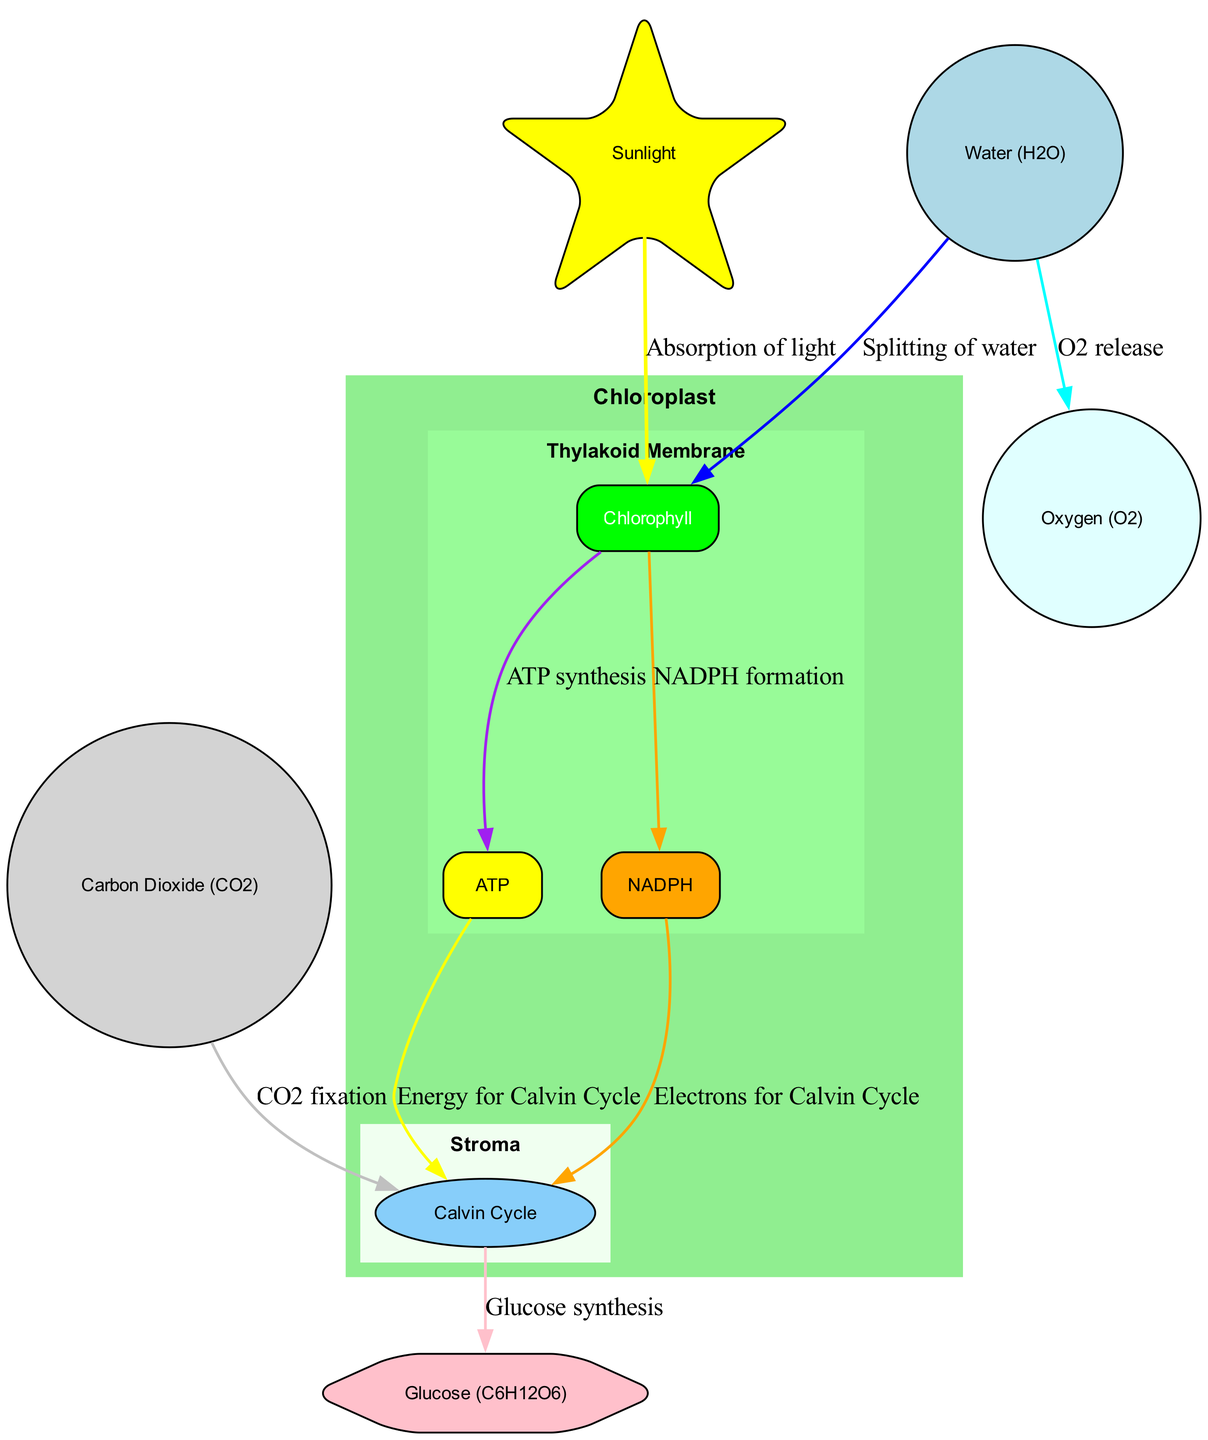What is the site of photosynthesis in plant cells? The diagram indicates that chloroplasts are the site of photosynthesis in plant cells, as labeled.
Answer: Chloroplast How many main components are identified in the chloroplast? The diagram lists six main components: Chloroplast, Thylakoid Membrane, Stroma, Sunlight, Water, and Carbon Dioxide. Counting these nodes gives a total of six.
Answer: Six Which molecule is formed as a byproduct of splitting water? The edges of the diagram show that the splitting of water releases oxygen, as indicated between the water node and the oxygen node.
Answer: Oxygen What process occurs in the stroma? The diagram connects the stroma to the Calvin Cycle, indicating that this process occurs in the stroma.
Answer: Calvin Cycle Which input is required for glucose synthesis? The flow from the Calvin Cycle to glucose indicates that the inputs leading to glucose synthesis include ATP, NADPH, and carbon dioxide, but since the question specifies one, we'll focus on carbon dioxide as it directly links to the Calvin cycle.
Answer: Carbon Dioxide Through which stages does sunlight energy get converted? The diagram traces the flow from sunlight to chlorophyll, leading to ATP and NADPH formation, where sunlight energy is effectively converted into chemical energy. The reasoning involves following the edges from sunlight to each resulting energy carrier molecule sequentially.
Answer: ATP and NADPH What is the role of chlorophyll in photosynthesis? Chlorophyll is shown as essential for the absorption of light energy; this is indicated directly on the diagram between sunlight and the chlorophyll node.
Answer: Absorption of light Which two molecules provide energy for the Calvin Cycle? The diagram presents two edges leading to the Calvin Cycle from ATP and NADPH, both represent energy and electron carriers essential for the cycle's functions.
Answer: ATP and NADPH How is glucose formed according to the diagram? The diagram outlines a flow from the Calvin Cycle that directly leads to glucose synthesis, establishing that glucose is produced as a product of the Calvin Cycle. This conclusion is reached by examining the arrows leading out from the Calvin Cycle.
Answer: Glucose 